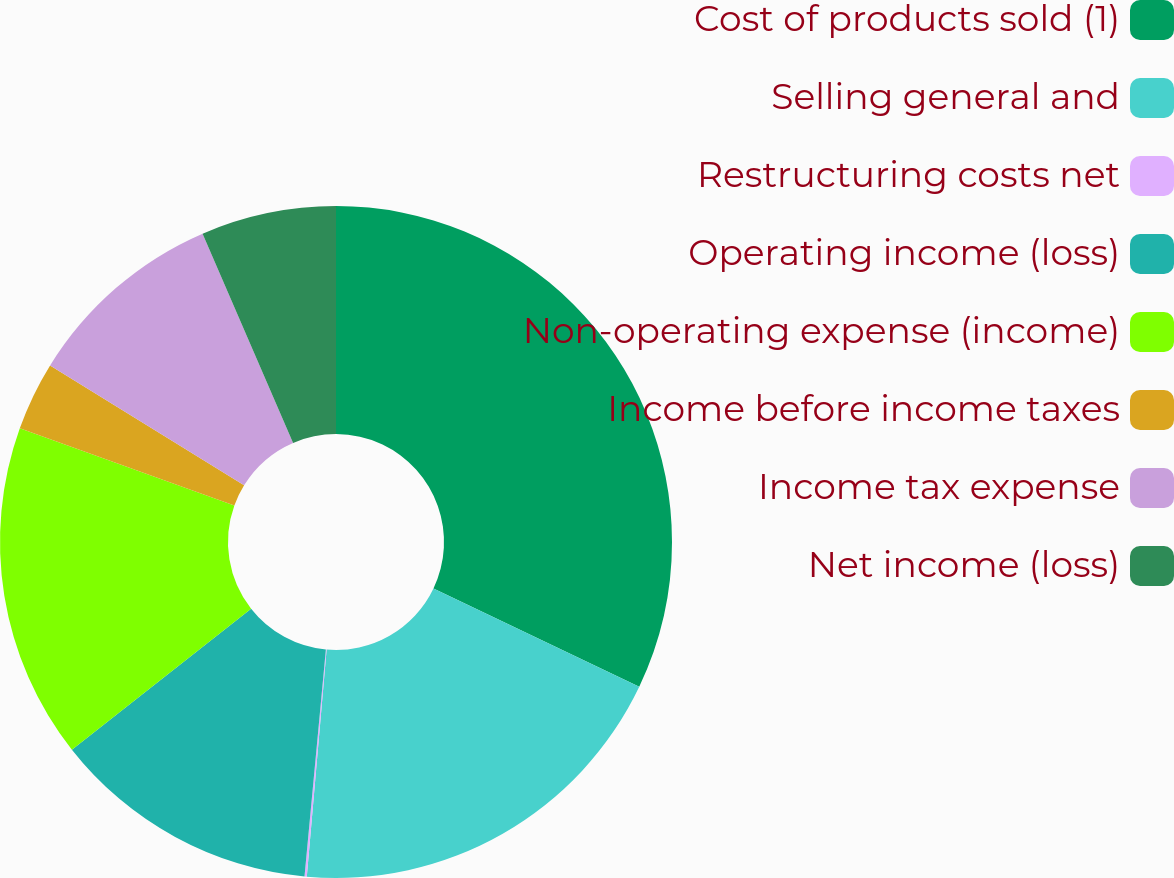Convert chart. <chart><loc_0><loc_0><loc_500><loc_500><pie_chart><fcel>Cost of products sold (1)<fcel>Selling general and<fcel>Restructuring costs net<fcel>Operating income (loss)<fcel>Non-operating expense (income)<fcel>Income before income taxes<fcel>Income tax expense<fcel>Net income (loss)<nl><fcel>32.09%<fcel>19.3%<fcel>0.11%<fcel>12.9%<fcel>16.1%<fcel>3.31%<fcel>9.7%<fcel>6.5%<nl></chart> 